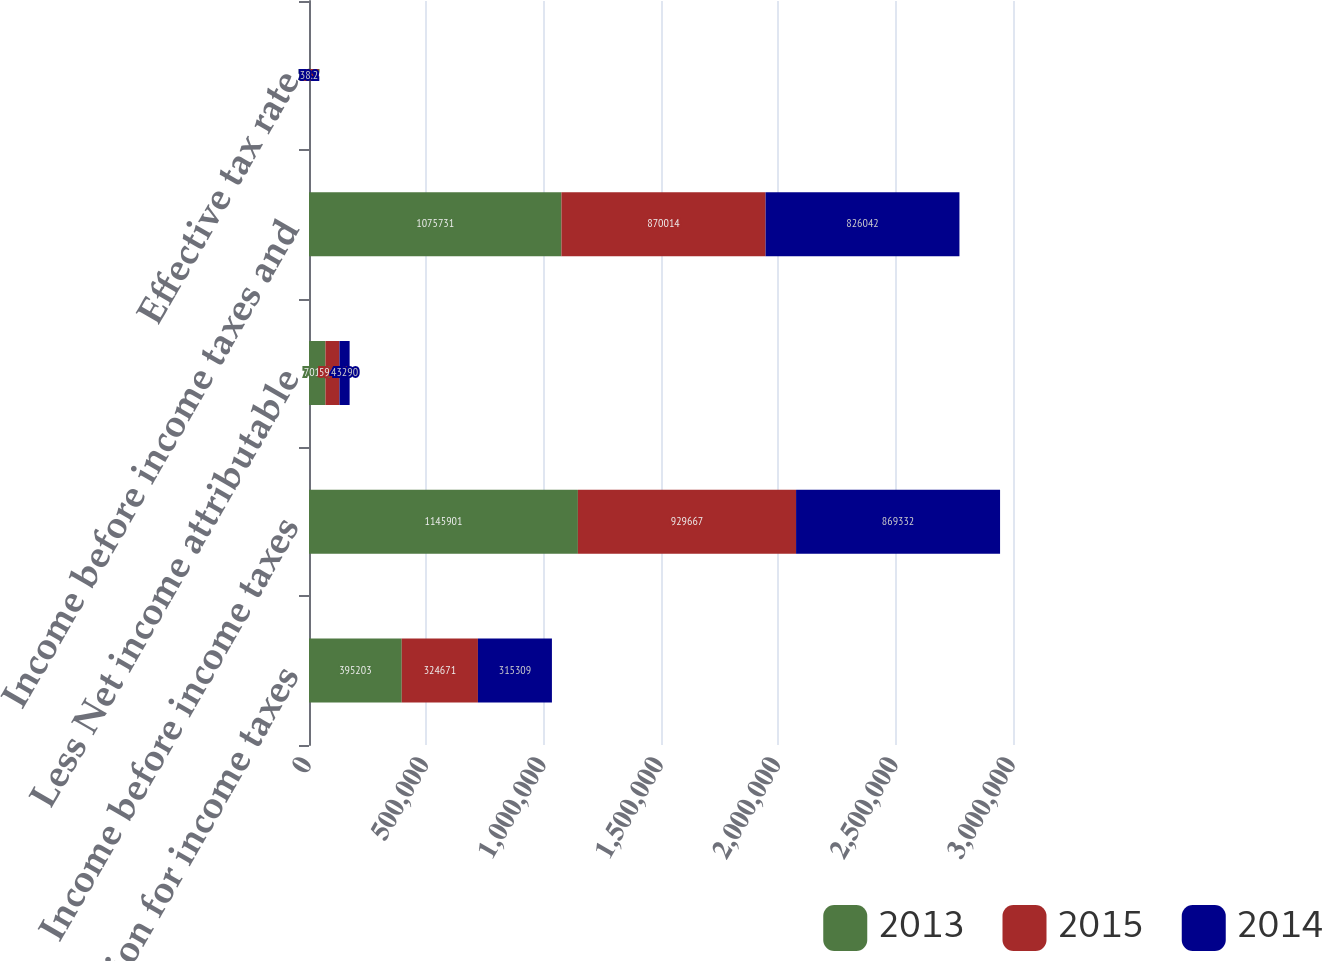Convert chart. <chart><loc_0><loc_0><loc_500><loc_500><stacked_bar_chart><ecel><fcel>Provision for income taxes<fcel>Income before income taxes<fcel>Less Net income attributable<fcel>Income before income taxes and<fcel>Effective tax rate<nl><fcel>2013<fcel>395203<fcel>1.1459e+06<fcel>70170<fcel>1.07573e+06<fcel>36.7<nl><fcel>2015<fcel>324671<fcel>929667<fcel>59653<fcel>870014<fcel>37.3<nl><fcel>2014<fcel>315309<fcel>869332<fcel>43290<fcel>826042<fcel>38.2<nl></chart> 